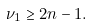Convert formula to latex. <formula><loc_0><loc_0><loc_500><loc_500>\nu _ { 1 } \geq 2 n - 1 .</formula> 